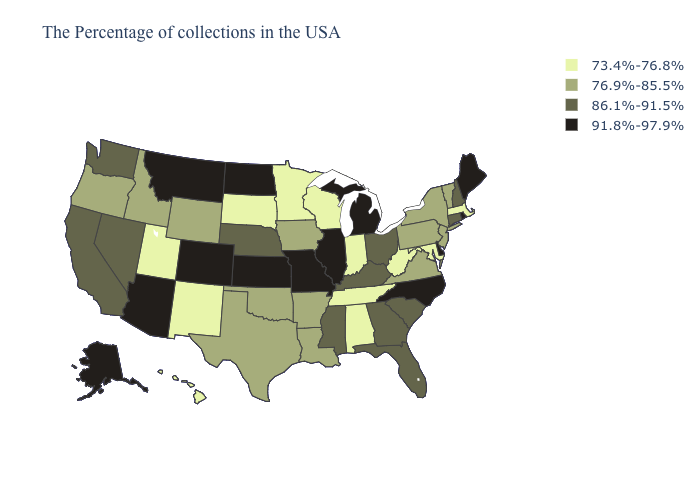Does Pennsylvania have the same value as New Mexico?
Be succinct. No. Name the states that have a value in the range 76.9%-85.5%?
Keep it brief. Vermont, New York, New Jersey, Pennsylvania, Virginia, Louisiana, Arkansas, Iowa, Oklahoma, Texas, Wyoming, Idaho, Oregon. Name the states that have a value in the range 86.1%-91.5%?
Be succinct. New Hampshire, Connecticut, South Carolina, Ohio, Florida, Georgia, Kentucky, Mississippi, Nebraska, Nevada, California, Washington. What is the value of North Carolina?
Concise answer only. 91.8%-97.9%. Does Colorado have the lowest value in the West?
Be succinct. No. Which states hav the highest value in the Northeast?
Quick response, please. Maine, Rhode Island. Which states have the highest value in the USA?
Answer briefly. Maine, Rhode Island, Delaware, North Carolina, Michigan, Illinois, Missouri, Kansas, North Dakota, Colorado, Montana, Arizona, Alaska. What is the value of Virginia?
Quick response, please. 76.9%-85.5%. What is the value of Wyoming?
Keep it brief. 76.9%-85.5%. What is the value of Massachusetts?
Keep it brief. 73.4%-76.8%. Does Indiana have the lowest value in the MidWest?
Short answer required. Yes. Does Vermont have the lowest value in the USA?
Be succinct. No. Does Wisconsin have a lower value than Connecticut?
Write a very short answer. Yes. Which states have the lowest value in the West?
Write a very short answer. New Mexico, Utah, Hawaii. Does Oregon have the same value as Massachusetts?
Give a very brief answer. No. 